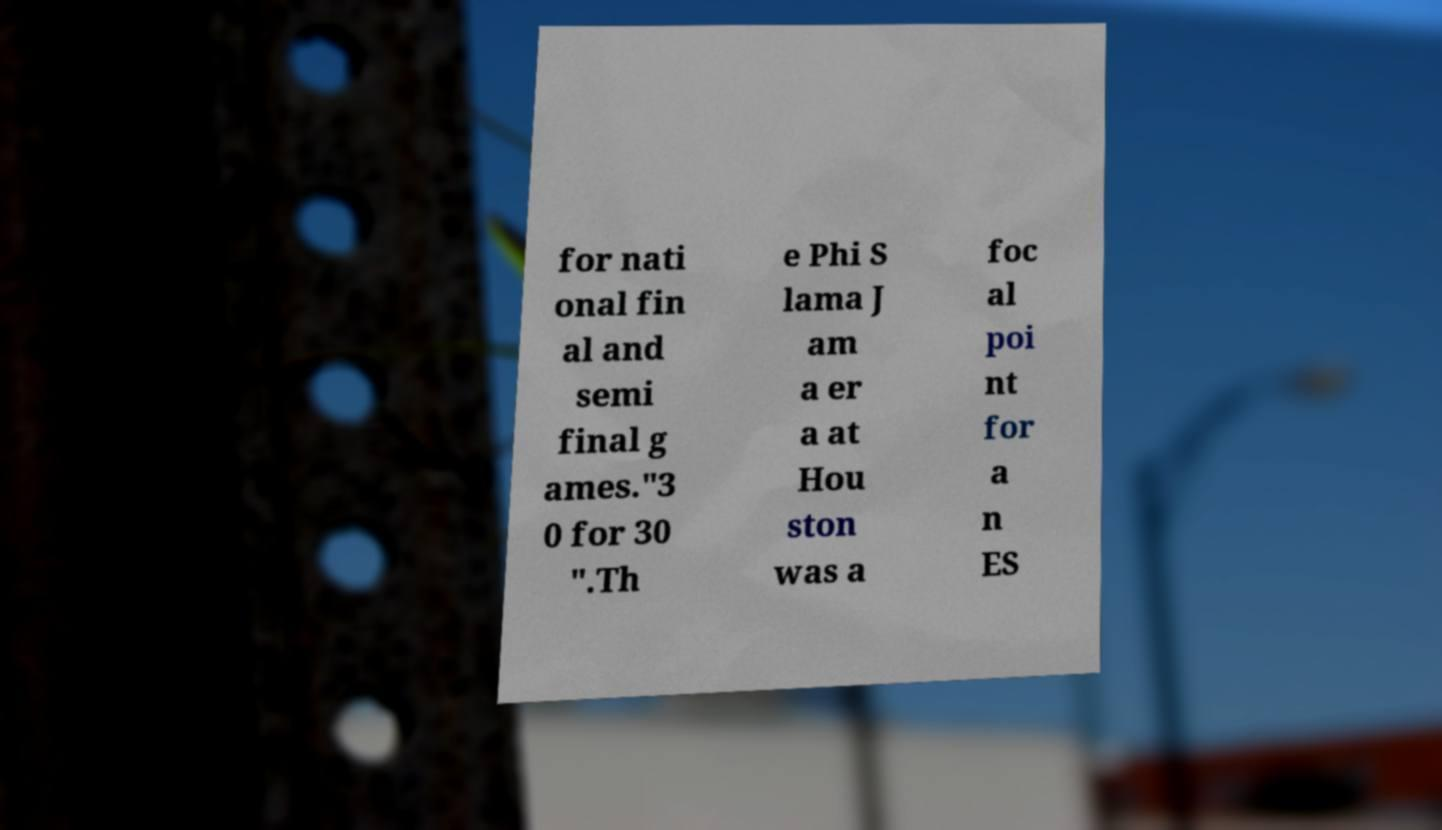There's text embedded in this image that I need extracted. Can you transcribe it verbatim? for nati onal fin al and semi final g ames."3 0 for 30 ".Th e Phi S lama J am a er a at Hou ston was a foc al poi nt for a n ES 